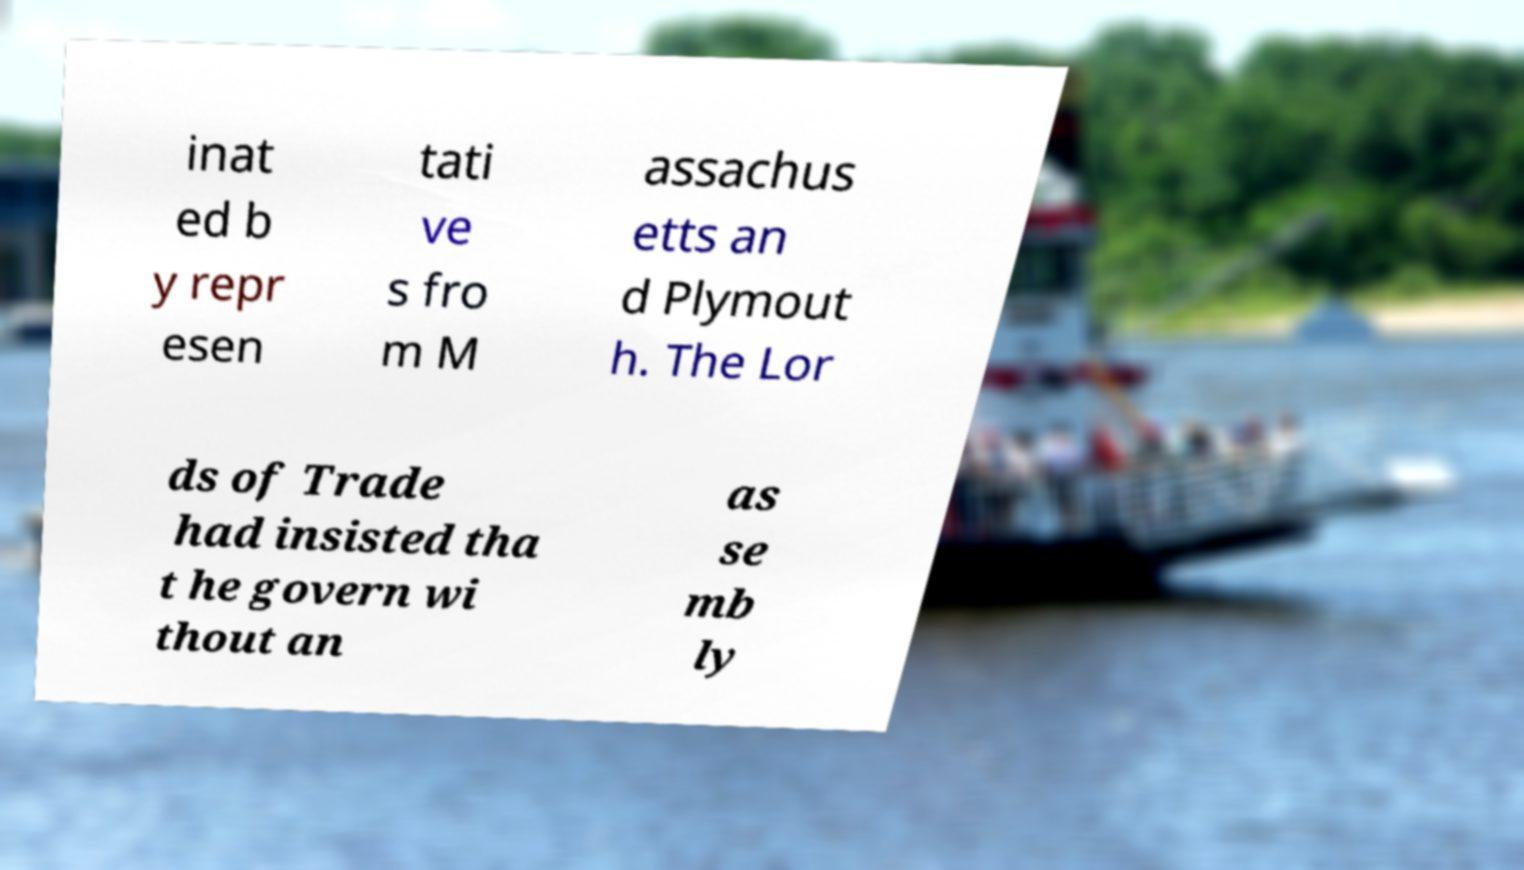There's text embedded in this image that I need extracted. Can you transcribe it verbatim? inat ed b y repr esen tati ve s fro m M assachus etts an d Plymout h. The Lor ds of Trade had insisted tha t he govern wi thout an as se mb ly 